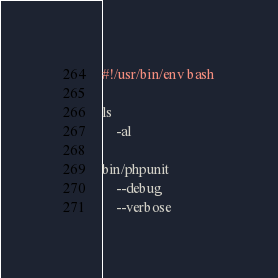Convert code to text. <code><loc_0><loc_0><loc_500><loc_500><_Bash_>#!/usr/bin/env bash

ls
    -al

bin/phpunit
    --debug
    --verbose</code> 